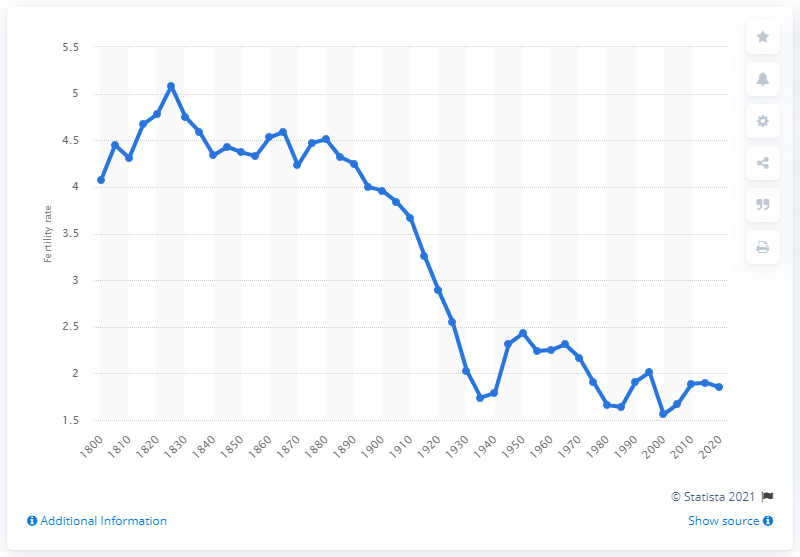Identify some key points in this picture. It is estimated that by 2020, the fertility rate of Sweden will be 1.9 children per woman. 